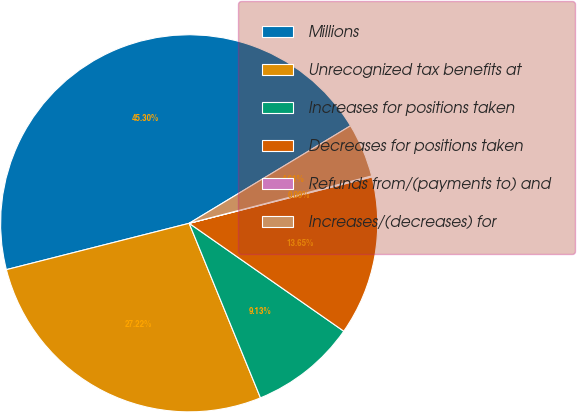Convert chart to OTSL. <chart><loc_0><loc_0><loc_500><loc_500><pie_chart><fcel>Millions<fcel>Unrecognized tax benefits at<fcel>Increases for positions taken<fcel>Decreases for positions taken<fcel>Refunds from/(payments to) and<fcel>Increases/(decreases) for<nl><fcel>45.3%<fcel>27.22%<fcel>9.13%<fcel>13.65%<fcel>0.09%<fcel>4.61%<nl></chart> 